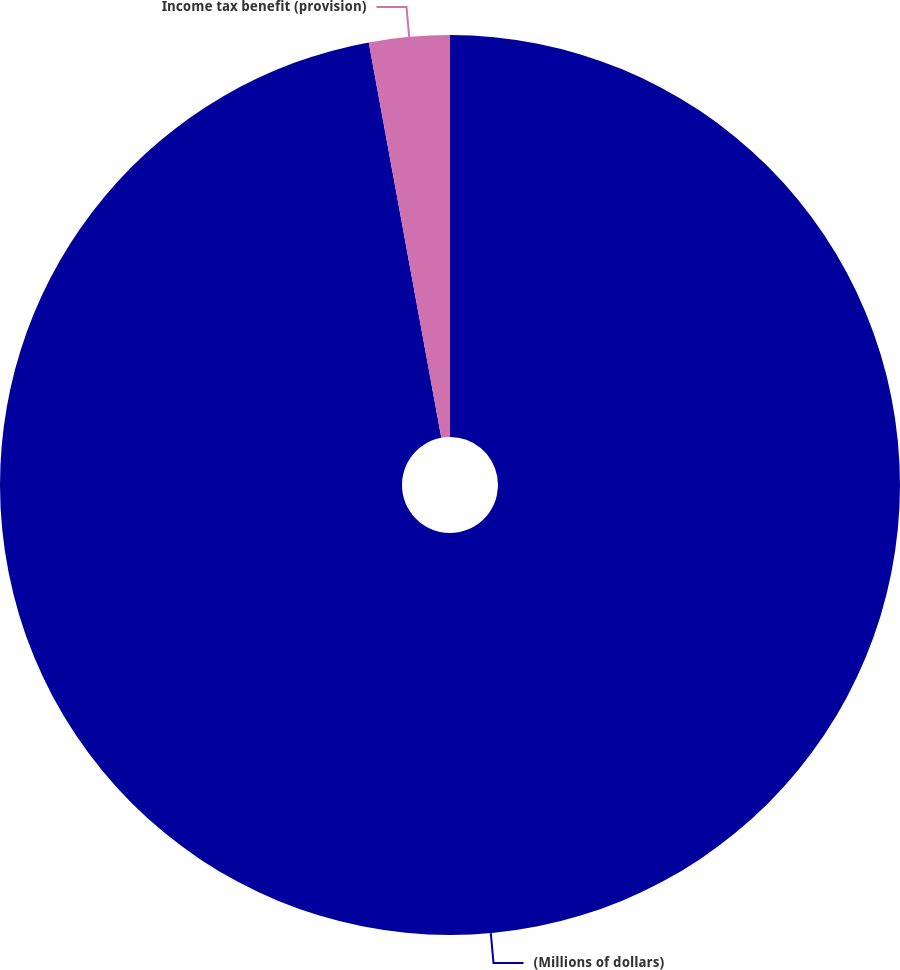Convert chart. <chart><loc_0><loc_0><loc_500><loc_500><pie_chart><fcel>(Millions of dollars)<fcel>Income tax benefit (provision)<nl><fcel>97.11%<fcel>2.89%<nl></chart> 